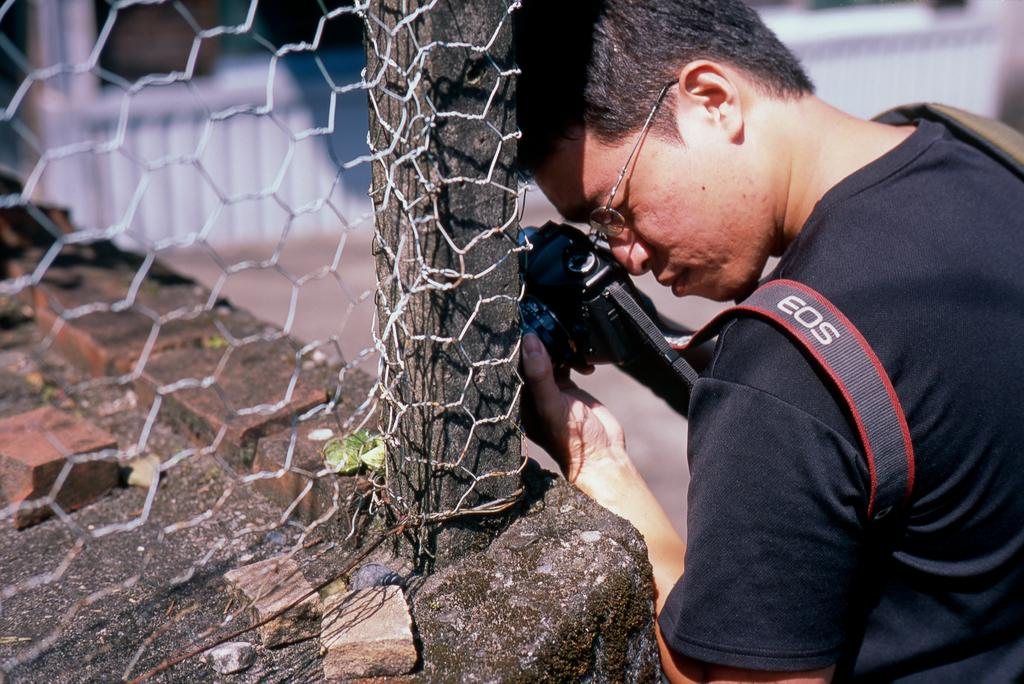What is present on the right side of the image? There is a person on the right side of the image. What is the person holding in the image? The person is holding a camera in the image. What can be seen on the person's face? The person is wearing specs in the image. What is the person wearing? The person is wearing a black dress in the image. What type of quiver can be seen on the person's back in the image? There is no quiver present on the person's back in the image. What type of bushes can be seen growing near the fence in the image? The provided facts do not mention any bushes near the fence in the image. 